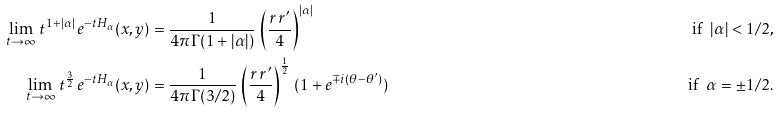Convert formula to latex. <formula><loc_0><loc_0><loc_500><loc_500>\lim _ { t \to \infty } \, t ^ { 1 + | \alpha | } \, e ^ { - t H _ { \alpha } } ( x , y ) & = \frac { 1 } { 4 \pi \Gamma ( 1 + | \alpha | ) } \, \left ( \frac { r \, r ^ { \prime } } { 4 } \right ) ^ { | \alpha | } & \quad \text {if\, } | \alpha | < 1 / 2 , \\ \lim _ { t \to \infty } \, t ^ { \frac { 3 } { 2 } } \, e ^ { - t H _ { \alpha } } ( x , y ) & = \frac { 1 } { 4 \pi \Gamma ( 3 / 2 ) } \, \left ( \frac { r \, r ^ { \prime } } { 4 } \right ) ^ { \frac { 1 } { 2 } } \, ( 1 + e ^ { \mp i ( \theta - \theta ^ { \prime } ) } ) & \quad \text {if\, } \alpha = \pm 1 / 2 .</formula> 